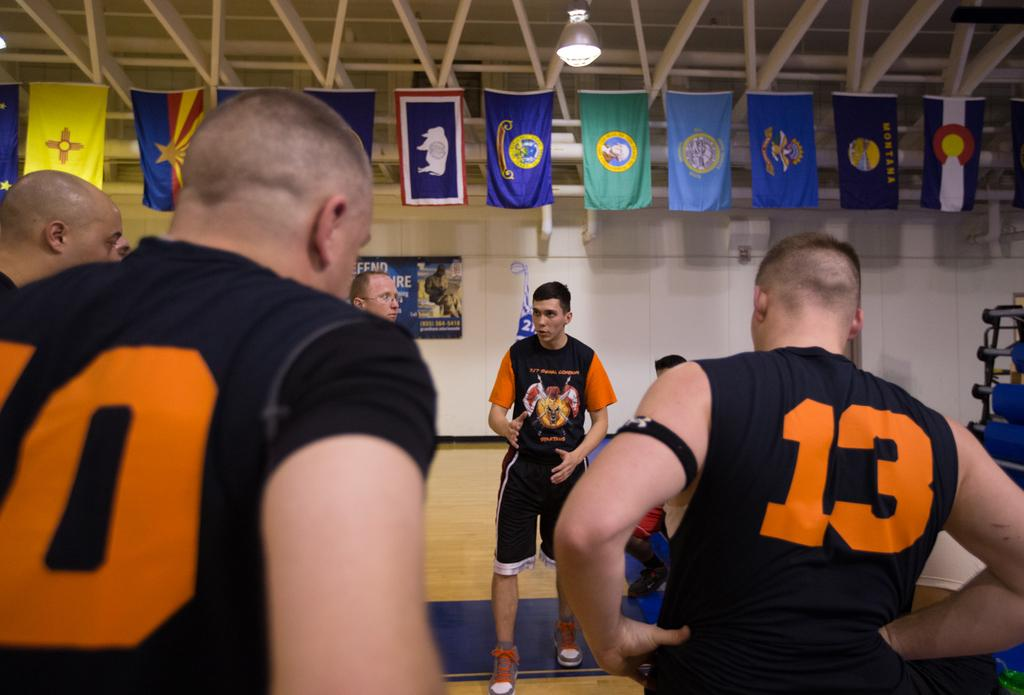<image>
Create a compact narrative representing the image presented. Man wearing a shirt saying number 13 next to a man wearing a shirt that says number 10. 